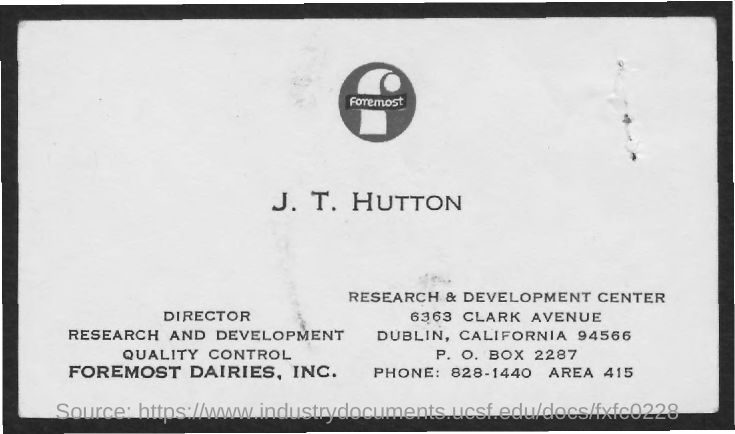Identify some key points in this picture. The person in charge of Research and Development Quality Control is J.T. Hutton. The phone number mentioned in the document is 828-1440. The area mentioned in the document is 415.. The PO Box number mentioned in the document is 2287. The text written in the image is 'Foremost.' 